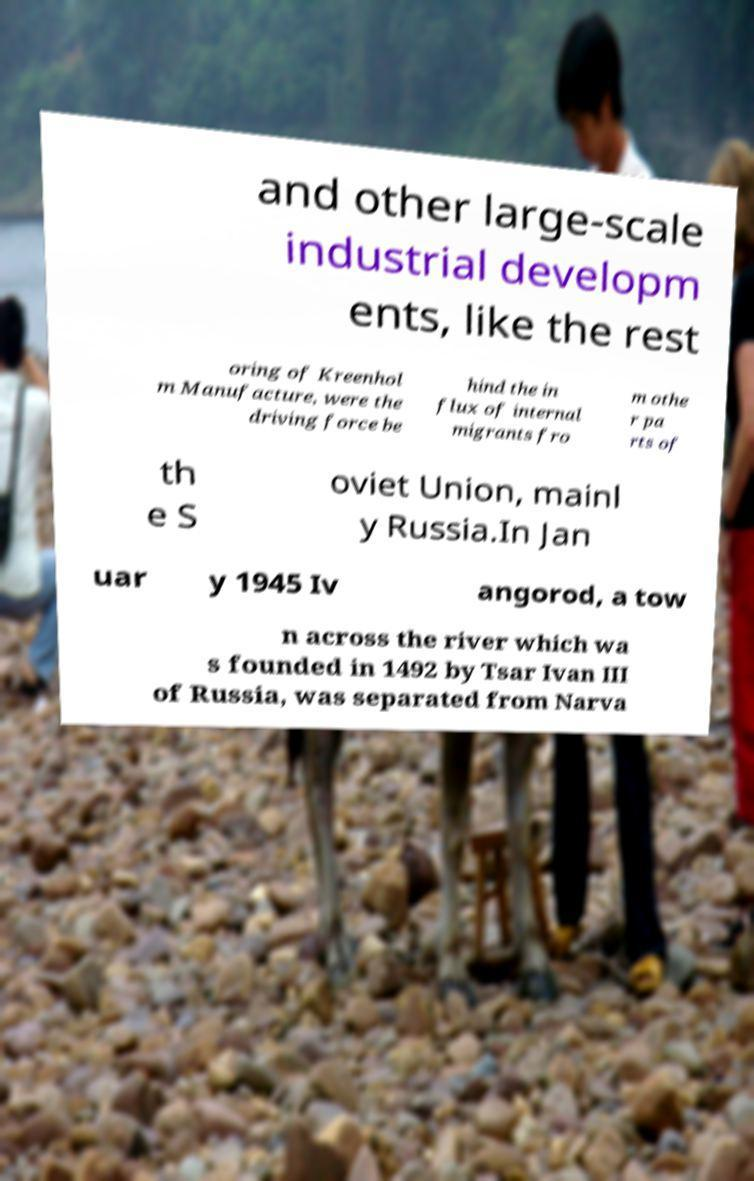Can you accurately transcribe the text from the provided image for me? and other large-scale industrial developm ents, like the rest oring of Kreenhol m Manufacture, were the driving force be hind the in flux of internal migrants fro m othe r pa rts of th e S oviet Union, mainl y Russia.In Jan uar y 1945 Iv angorod, a tow n across the river which wa s founded in 1492 by Tsar Ivan III of Russia, was separated from Narva 